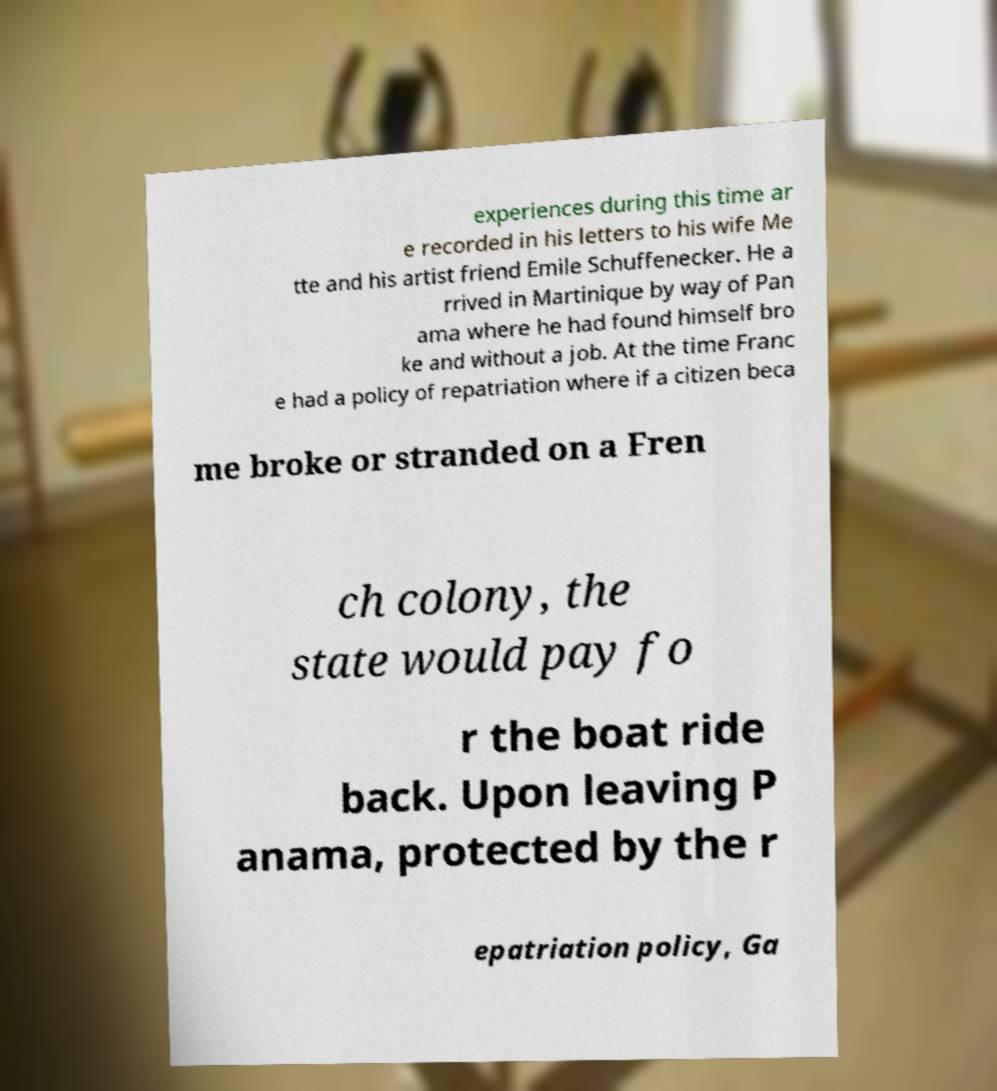Could you extract and type out the text from this image? experiences during this time ar e recorded in his letters to his wife Me tte and his artist friend Emile Schuffenecker. He a rrived in Martinique by way of Pan ama where he had found himself bro ke and without a job. At the time Franc e had a policy of repatriation where if a citizen beca me broke or stranded on a Fren ch colony, the state would pay fo r the boat ride back. Upon leaving P anama, protected by the r epatriation policy, Ga 